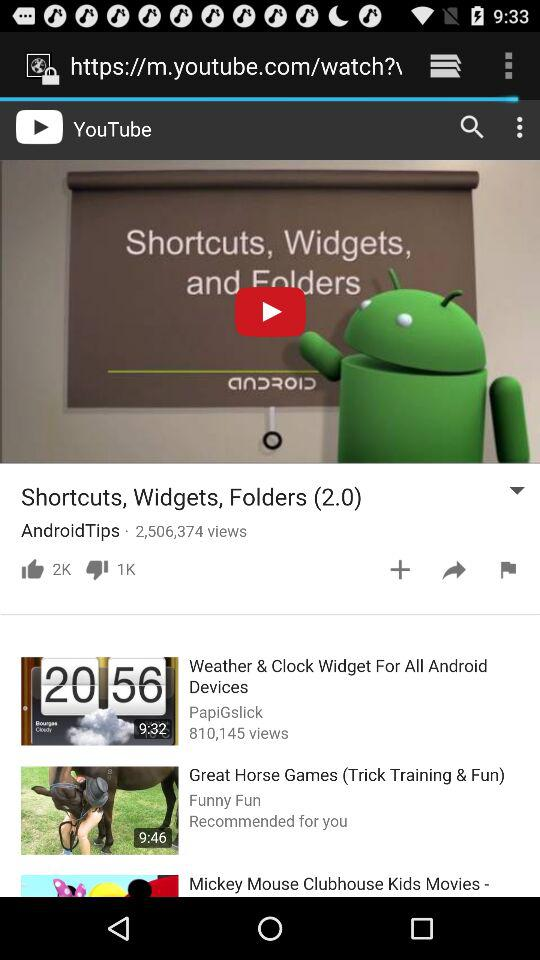What is the duration of "Mickey Mouse Clubhouse Kids Movies -"?
When the provided information is insufficient, respond with <no answer>. <no answer> 